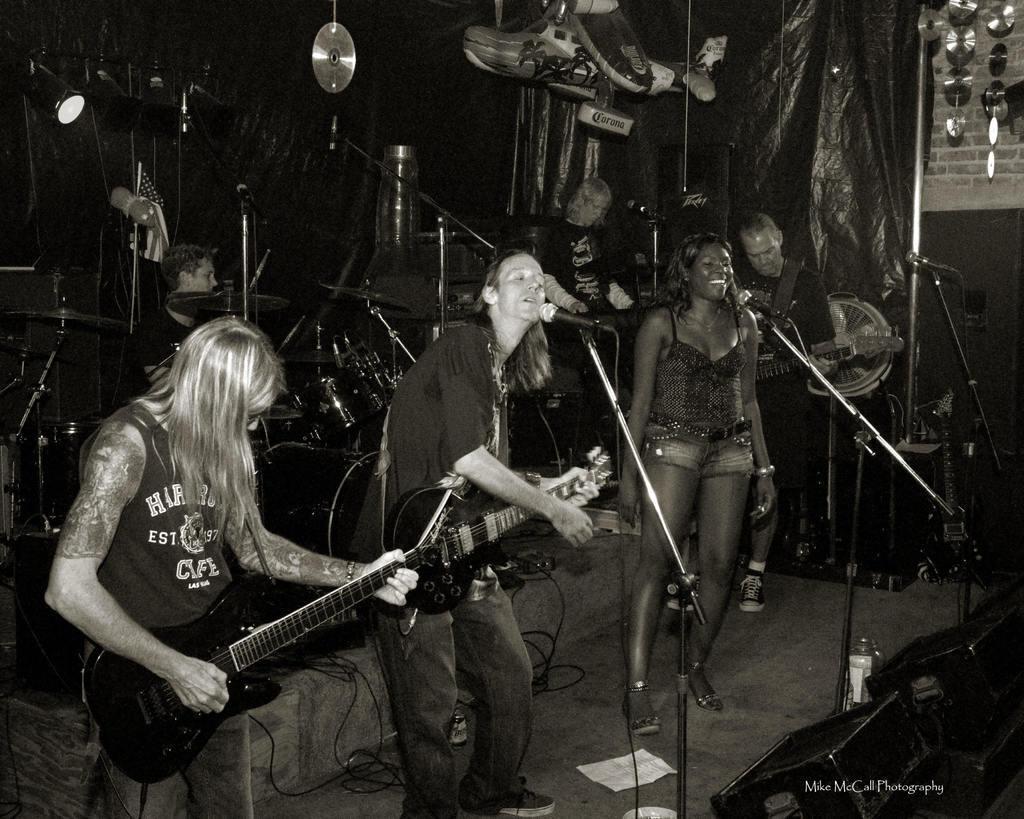Please provide a concise description of this image. In this picture we can see some people holding some musical instruments and playing them in front of the mics. 